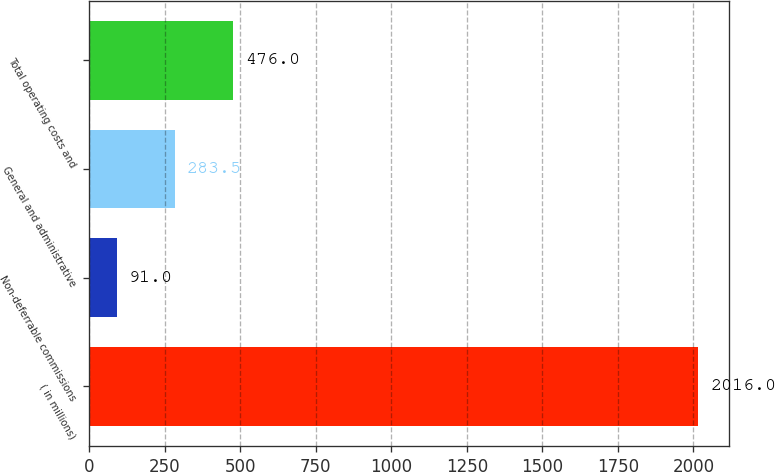Convert chart to OTSL. <chart><loc_0><loc_0><loc_500><loc_500><bar_chart><fcel>( in millions)<fcel>Non-deferrable commissions<fcel>General and administrative<fcel>Total operating costs and<nl><fcel>2016<fcel>91<fcel>283.5<fcel>476<nl></chart> 